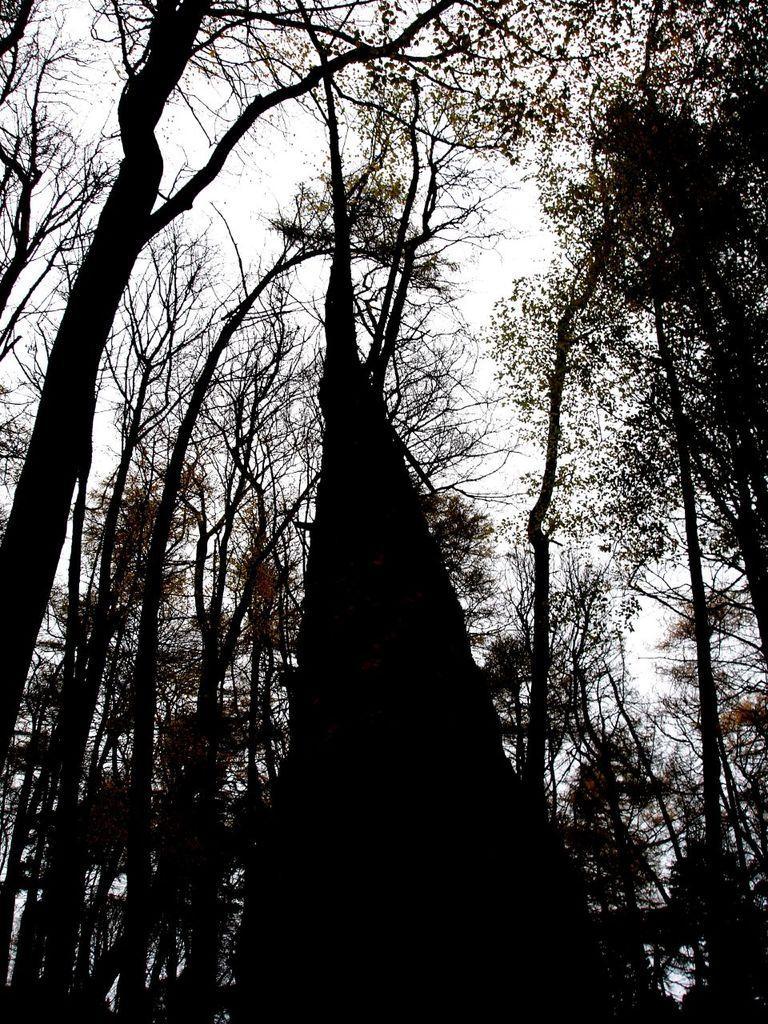Can you describe this image briefly? In the image we can see black and white picture of trees and the sky. 